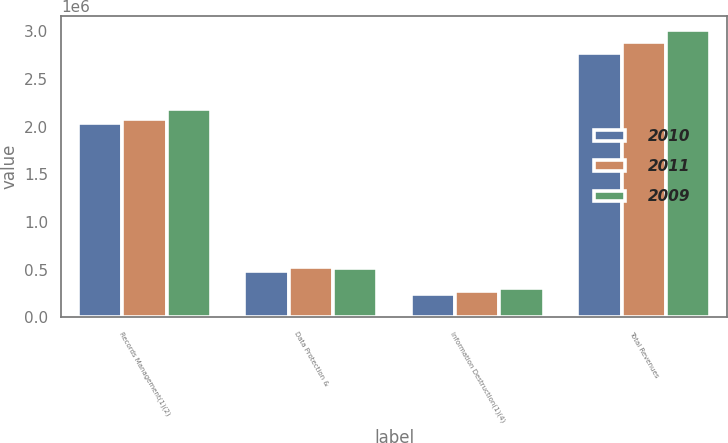Convert chart to OTSL. <chart><loc_0><loc_0><loc_500><loc_500><stacked_bar_chart><ecel><fcel>Records Management(1)(2)<fcel>Data Protection &<fcel>Information Destruction(1)(4)<fcel>Total Revenues<nl><fcel>2010<fcel>2.0405e+06<fcel>483909<fcel>249978<fcel>2.77438e+06<nl><fcel>2011<fcel>2.08149e+06<fcel>531580<fcel>279277<fcel>2.89235e+06<nl><fcel>2009<fcel>2.18315e+06<fcel>522632<fcel>308917<fcel>3.0147e+06<nl></chart> 